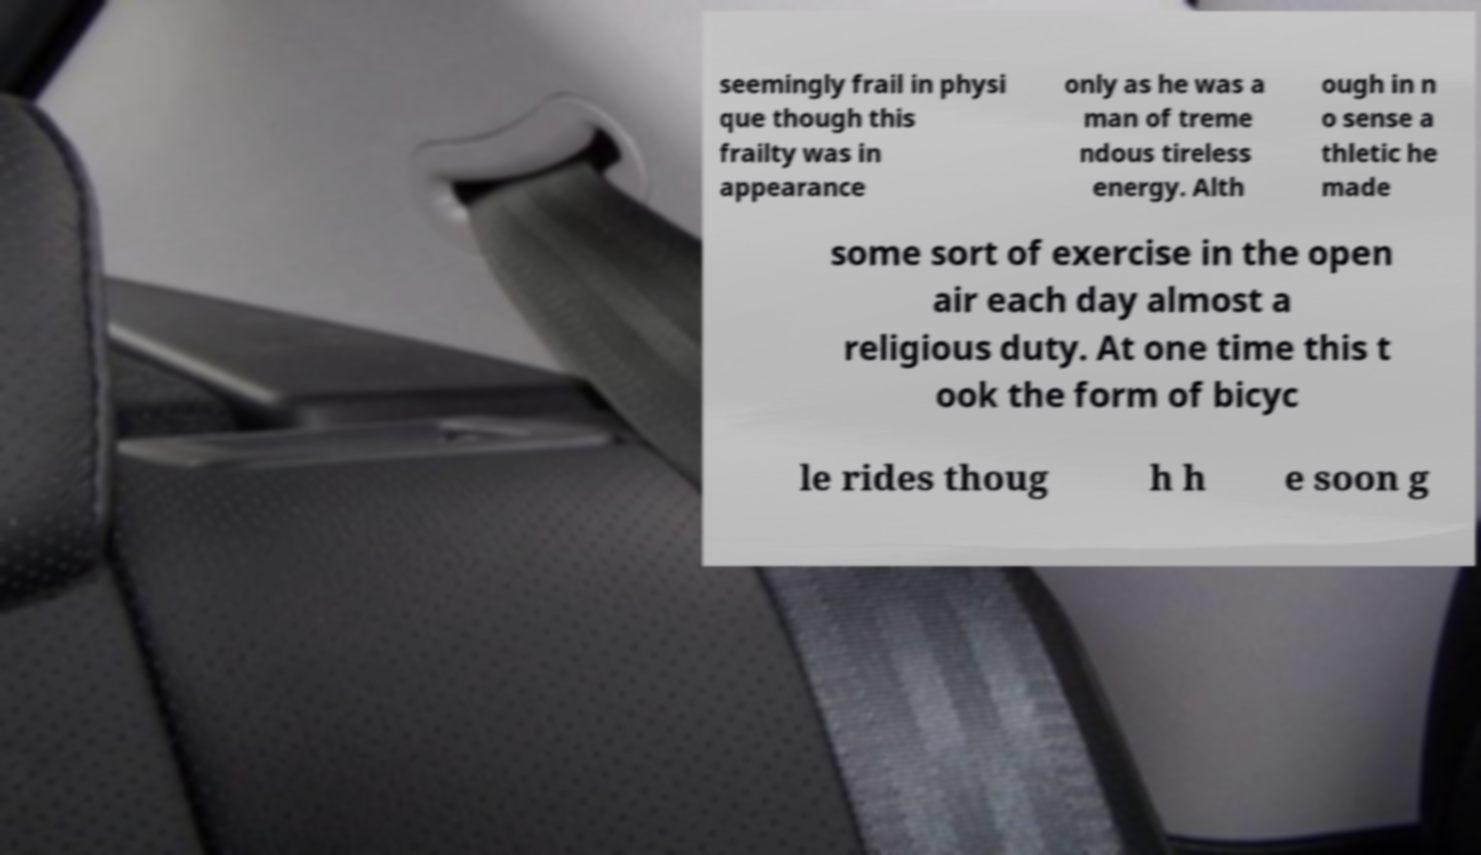Please identify and transcribe the text found in this image. seemingly frail in physi que though this frailty was in appearance only as he was a man of treme ndous tireless energy. Alth ough in n o sense a thletic he made some sort of exercise in the open air each day almost a religious duty. At one time this t ook the form of bicyc le rides thoug h h e soon g 